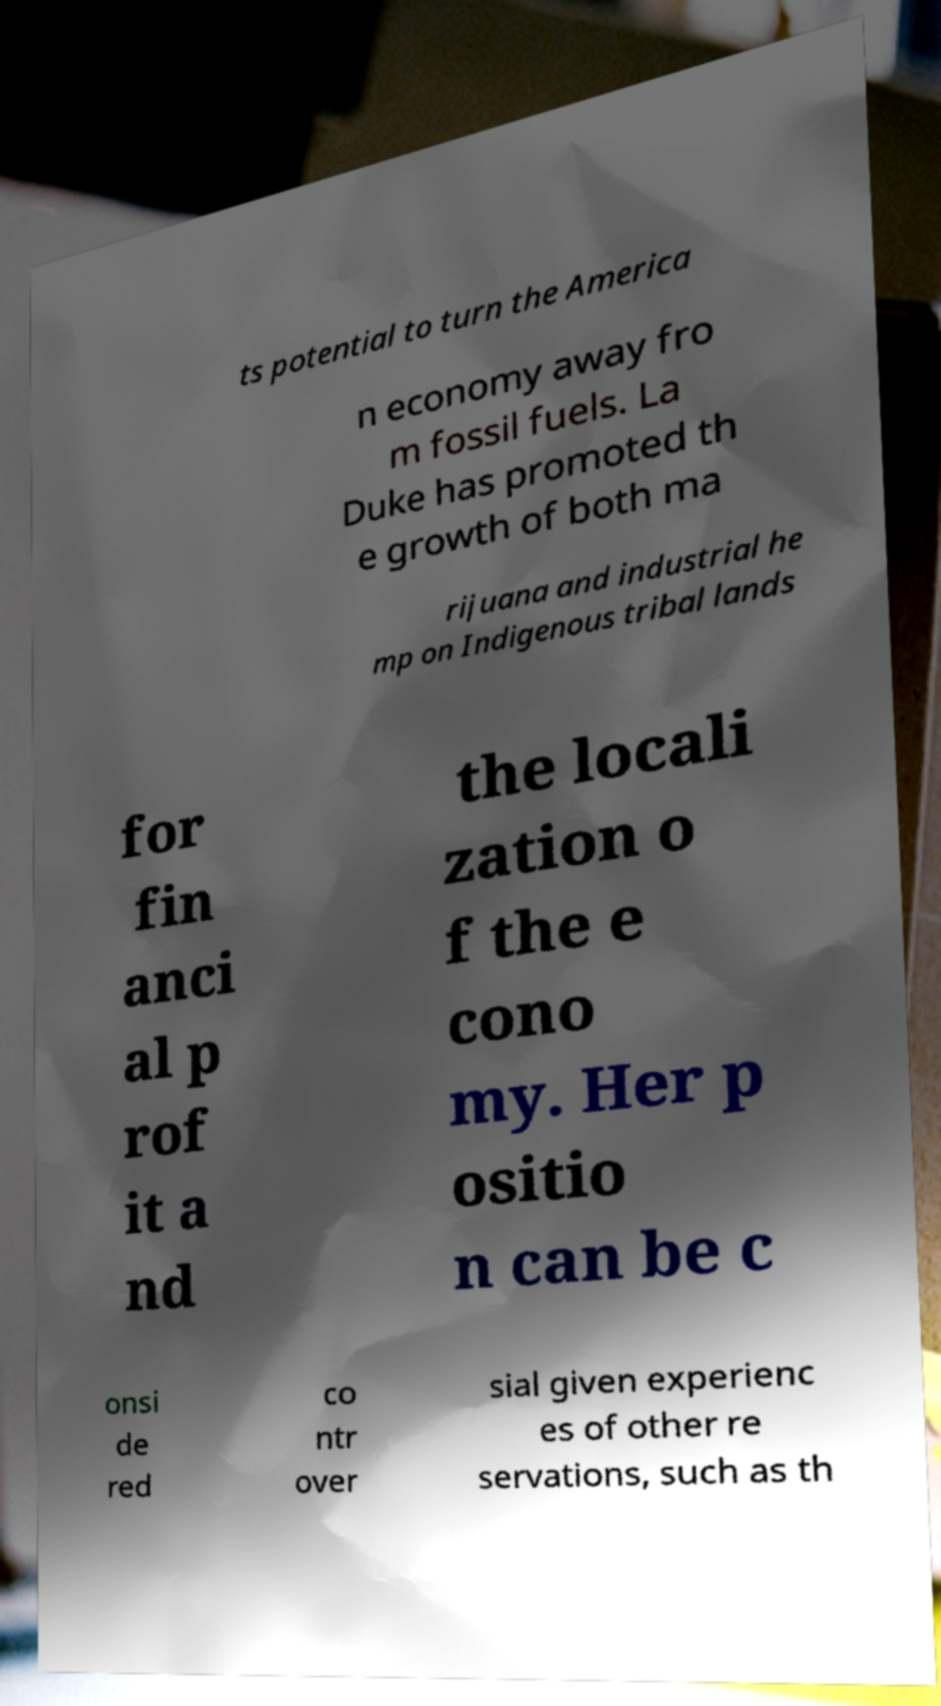Could you assist in decoding the text presented in this image and type it out clearly? ts potential to turn the America n economy away fro m fossil fuels. La Duke has promoted th e growth of both ma rijuana and industrial he mp on Indigenous tribal lands for fin anci al p rof it a nd the locali zation o f the e cono my. Her p ositio n can be c onsi de red co ntr over sial given experienc es of other re servations, such as th 